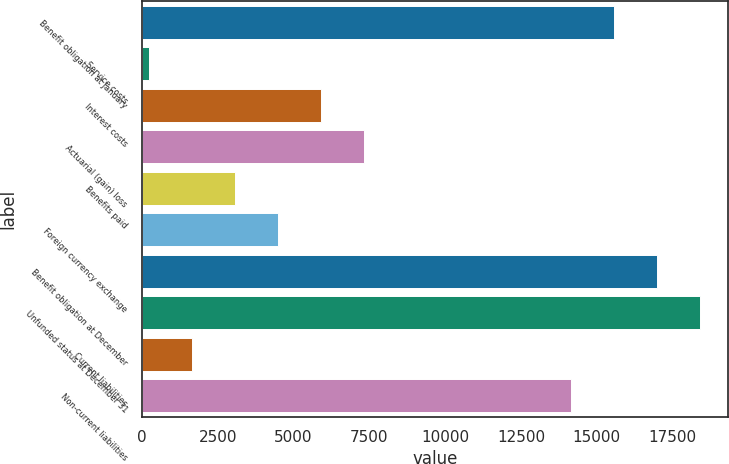Convert chart to OTSL. <chart><loc_0><loc_0><loc_500><loc_500><bar_chart><fcel>Benefit obligation at January<fcel>Service costs<fcel>Interest costs<fcel>Actuarial (gain) loss<fcel>Benefits paid<fcel>Foreign currency exchange<fcel>Benefit obligation at December<fcel>Unfunded status at December 31<fcel>Current liabilities<fcel>Non-current liabilities<nl><fcel>15554.2<fcel>215<fcel>5903.8<fcel>7326<fcel>3059.4<fcel>4481.6<fcel>16976.4<fcel>18398.6<fcel>1637.2<fcel>14132<nl></chart> 